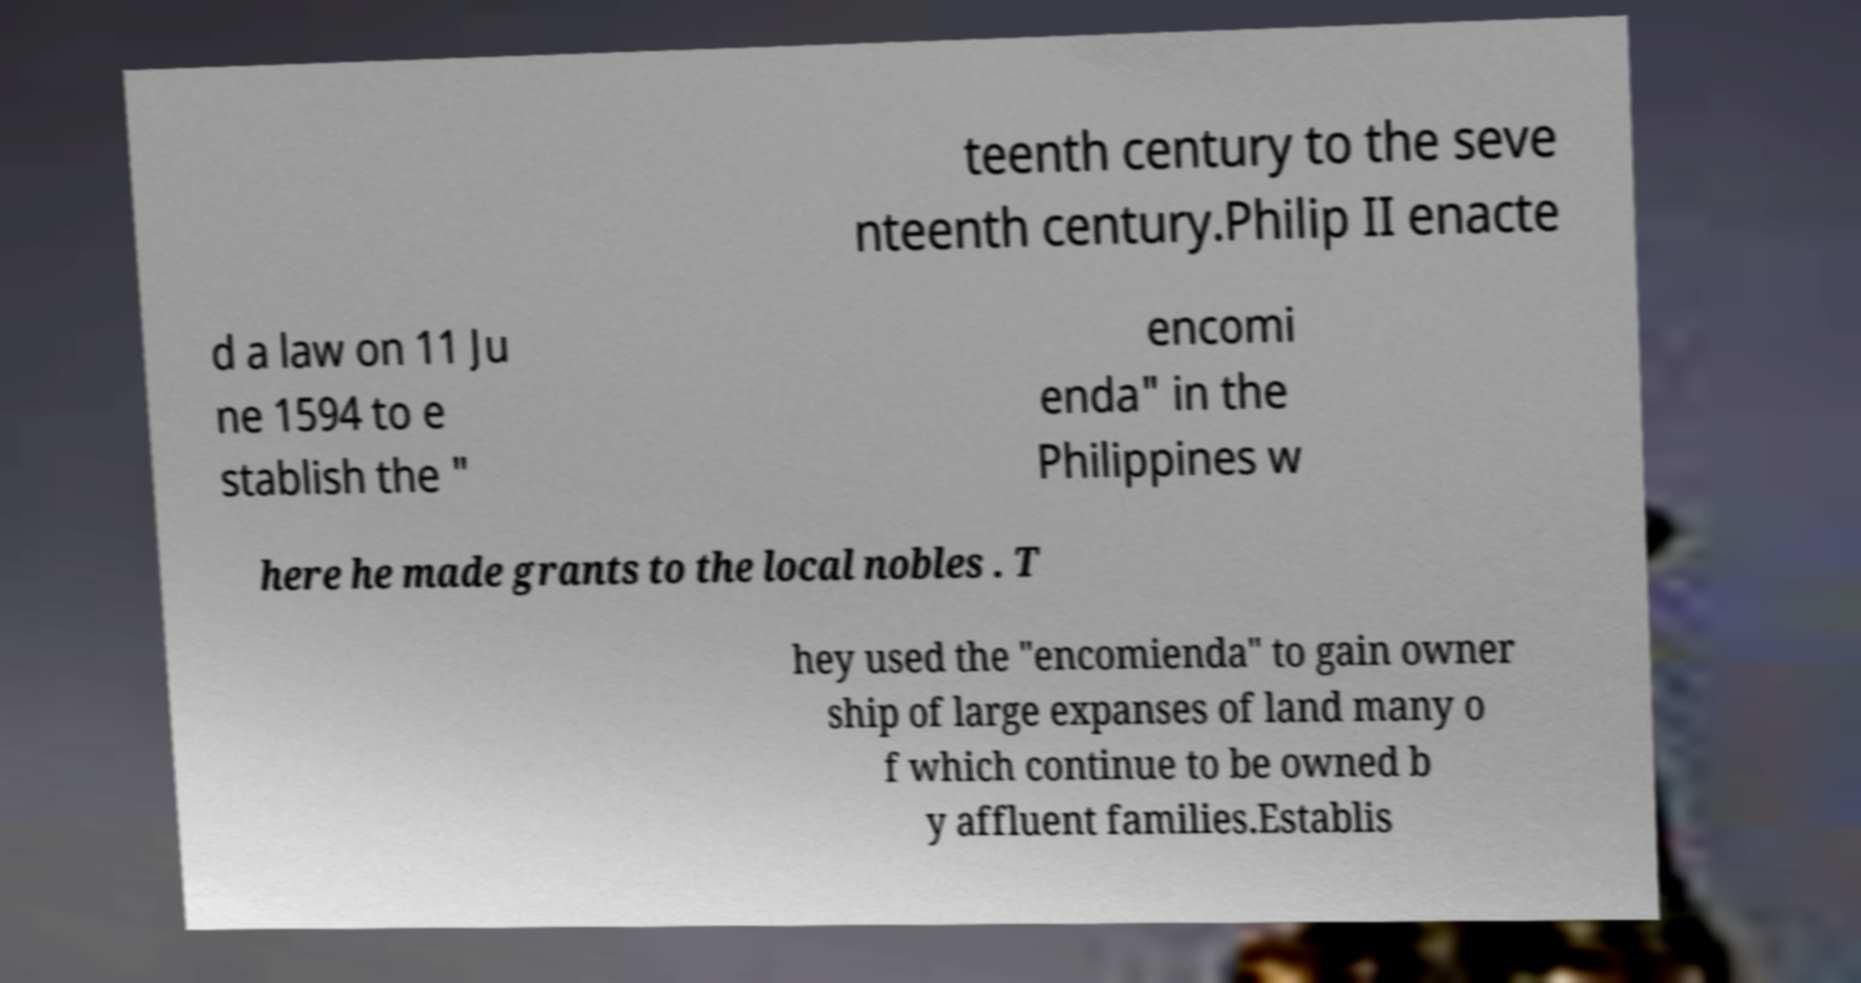What messages or text are displayed in this image? I need them in a readable, typed format. teenth century to the seve nteenth century.Philip II enacte d a law on 11 Ju ne 1594 to e stablish the " encomi enda" in the Philippines w here he made grants to the local nobles . T hey used the "encomienda" to gain owner ship of large expanses of land many o f which continue to be owned b y affluent families.Establis 